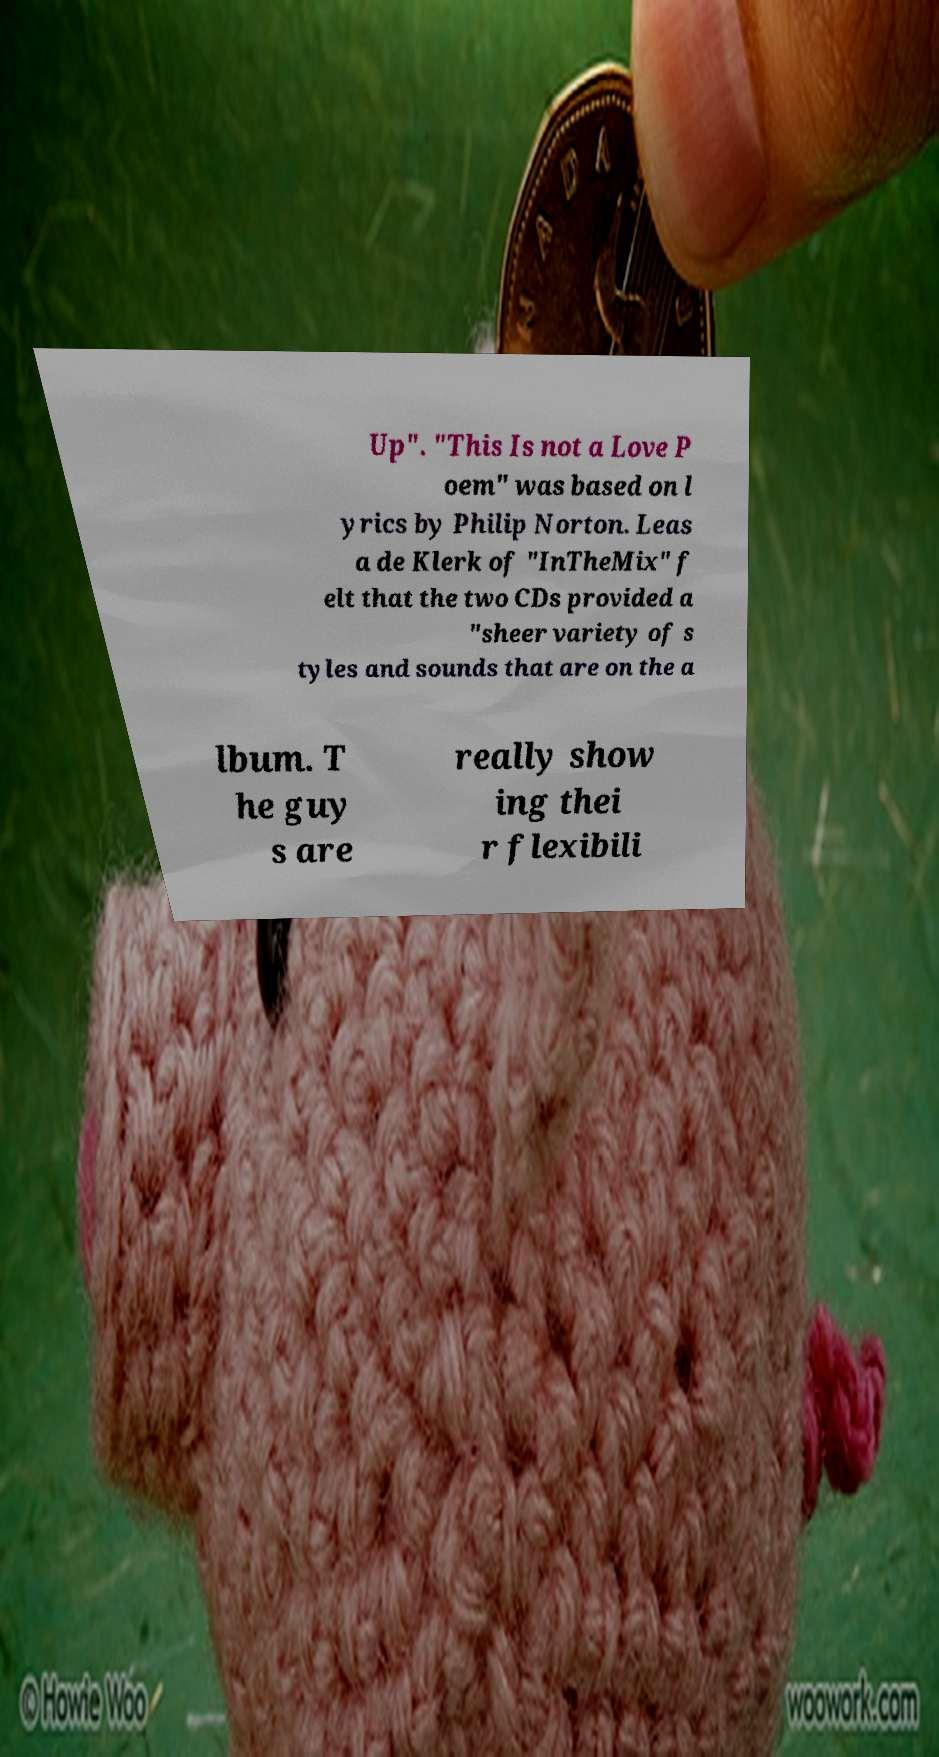Please identify and transcribe the text found in this image. Up". "This Is not a Love P oem" was based on l yrics by Philip Norton. Leas a de Klerk of "InTheMix" f elt that the two CDs provided a "sheer variety of s tyles and sounds that are on the a lbum. T he guy s are really show ing thei r flexibili 